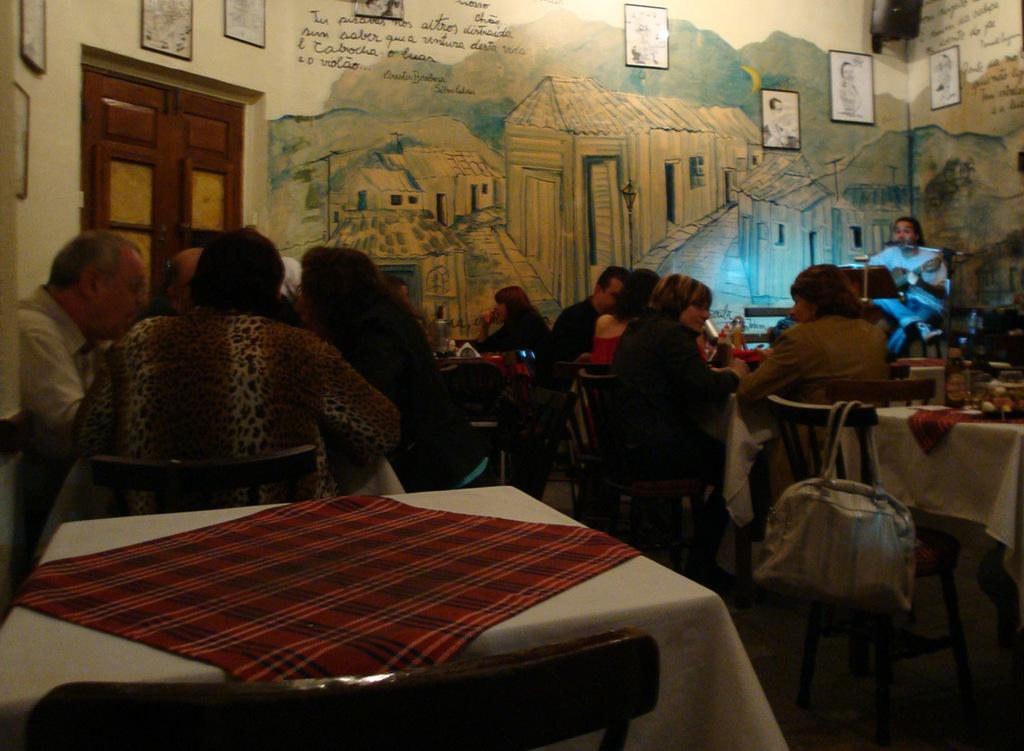What are the people in the image doing? The people in the image are sitting on chairs. What is present in the image besides the people? There is a table in the image. What is covering the table? There is a tablecloth on the table. What can be seen in the background of the image? There is a wall with paintings and a door in the background of the image. Can you tell me how many pigs are in the image? There are no pigs present in the image. What type of actor is performing in the image? There is no actor or performance in the image; it features people sitting on chairs, a table, and a background with paintings and a door. 